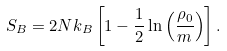Convert formula to latex. <formula><loc_0><loc_0><loc_500><loc_500>S _ { B } = 2 N k _ { B } \left [ 1 - \frac { 1 } { 2 } \ln \left ( \frac { \rho _ { 0 } } { m } \right ) \right ] .</formula> 